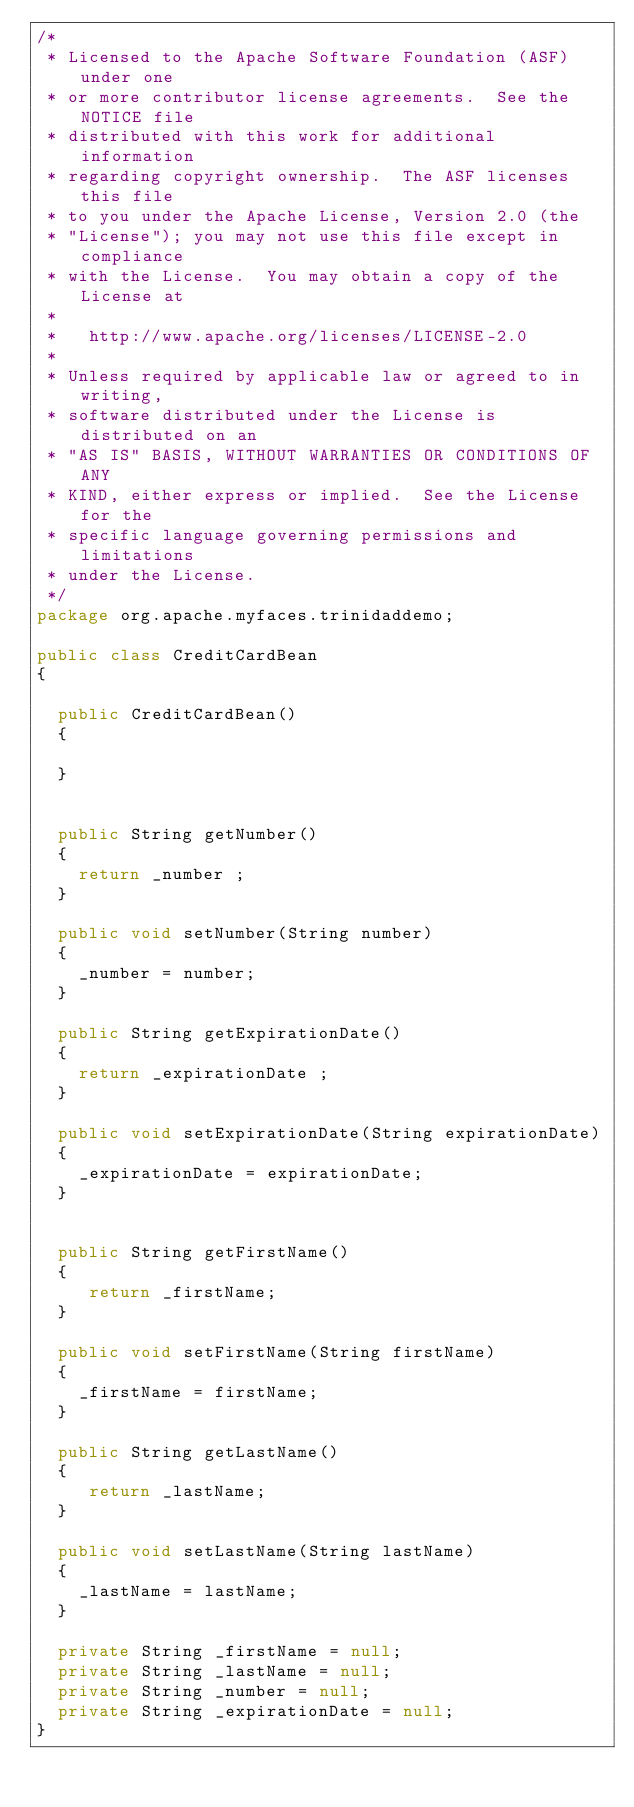Convert code to text. <code><loc_0><loc_0><loc_500><loc_500><_Java_>/*
 * Licensed to the Apache Software Foundation (ASF) under one
 * or more contributor license agreements.  See the NOTICE file
 * distributed with this work for additional information
 * regarding copyright ownership.  The ASF licenses this file
 * to you under the Apache License, Version 2.0 (the
 * "License"); you may not use this file except in compliance
 * with the License.  You may obtain a copy of the License at
 *
 *   http://www.apache.org/licenses/LICENSE-2.0
 *
 * Unless required by applicable law or agreed to in writing,
 * software distributed under the License is distributed on an
 * "AS IS" BASIS, WITHOUT WARRANTIES OR CONDITIONS OF ANY
 * KIND, either express or implied.  See the License for the
 * specific language governing permissions and limitations
 * under the License.
 */
package org.apache.myfaces.trinidaddemo;

public class CreditCardBean
{

  public CreditCardBean()
  {

  }


  public String getNumber()
  {
    return _number ;
  }

  public void setNumber(String number)
  {
    _number = number;
  }

  public String getExpirationDate()
  {
    return _expirationDate ;
  }

  public void setExpirationDate(String expirationDate)
  {
    _expirationDate = expirationDate;
  }


  public String getFirstName()
  {
     return _firstName;
  }

  public void setFirstName(String firstName)
  {
    _firstName = firstName;
  }

  public String getLastName()
  {
     return _lastName;
  }

  public void setLastName(String lastName)
  {
    _lastName = lastName;
  }

  private String _firstName = null;
  private String _lastName = null;
  private String _number = null;
  private String _expirationDate = null;
}

</code> 